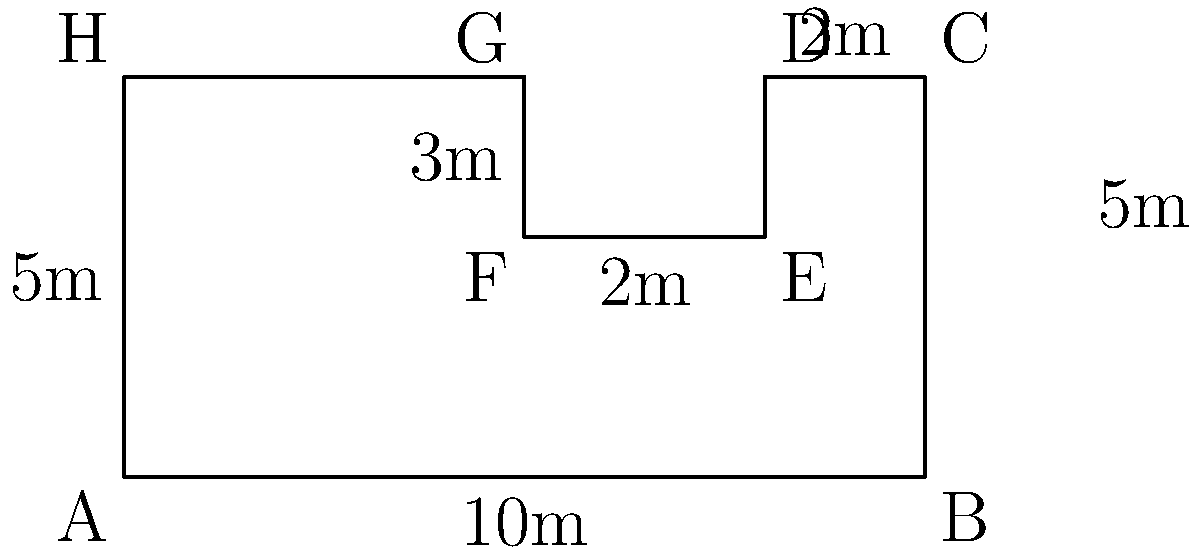As part of a new solar energy initiative, you're tasked with calculating the area of an irregularly shaped solar panel array for a government building. The array is composed of rectangular sections as shown in the diagram. All measurements are in meters. What is the total area of the solar panel array in square meters? To calculate the total area of the solar panel array, we'll break it down into rectangular sections and sum their areas:

1. Main rectangle (ABCH):
   Area = 10m × 5m = 50 m²

2. Subtract the small rectangle (DEFG):
   Area to subtract = 3m × 2m = 6 m²

Therefore, the total area is:

$$ \text{Total Area} = \text{Main Rectangle} - \text{Small Rectangle} $$
$$ \text{Total Area} = 50 \text{ m}^2 - 6 \text{ m}^2 = 44 \text{ m}^2 $$
Answer: 44 m² 